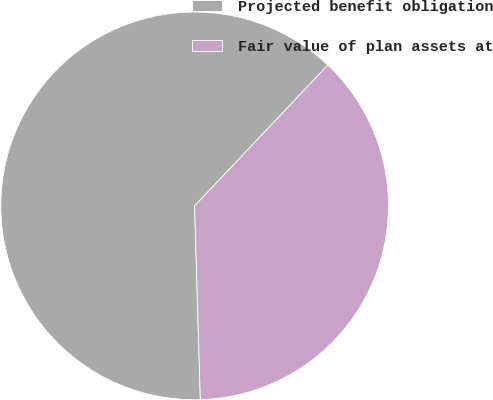Convert chart. <chart><loc_0><loc_0><loc_500><loc_500><pie_chart><fcel>Projected benefit obligation<fcel>Fair value of plan assets at<nl><fcel>62.53%<fcel>37.47%<nl></chart> 